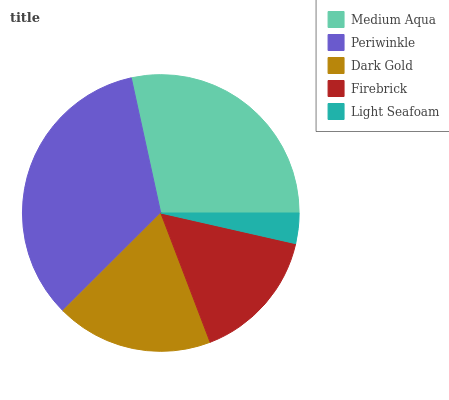Is Light Seafoam the minimum?
Answer yes or no. Yes. Is Periwinkle the maximum?
Answer yes or no. Yes. Is Dark Gold the minimum?
Answer yes or no. No. Is Dark Gold the maximum?
Answer yes or no. No. Is Periwinkle greater than Dark Gold?
Answer yes or no. Yes. Is Dark Gold less than Periwinkle?
Answer yes or no. Yes. Is Dark Gold greater than Periwinkle?
Answer yes or no. No. Is Periwinkle less than Dark Gold?
Answer yes or no. No. Is Dark Gold the high median?
Answer yes or no. Yes. Is Dark Gold the low median?
Answer yes or no. Yes. Is Firebrick the high median?
Answer yes or no. No. Is Periwinkle the low median?
Answer yes or no. No. 